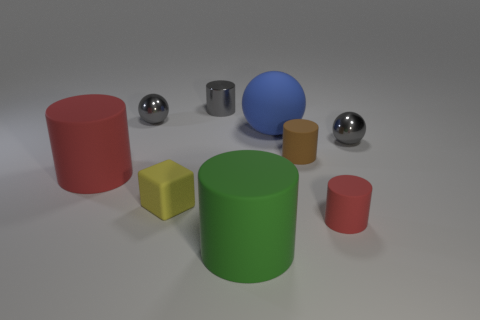Add 1 small brown objects. How many objects exist? 10 Subtract all small gray metal balls. How many balls are left? 1 Subtract 4 cylinders. How many cylinders are left? 1 Add 4 tiny things. How many tiny things exist? 10 Subtract all gray balls. How many balls are left? 1 Subtract 0 purple blocks. How many objects are left? 9 Subtract all cylinders. How many objects are left? 4 Subtract all green cylinders. Subtract all red balls. How many cylinders are left? 4 Subtract all gray cylinders. How many blue balls are left? 1 Subtract all tiny gray shiny cylinders. Subtract all gray objects. How many objects are left? 5 